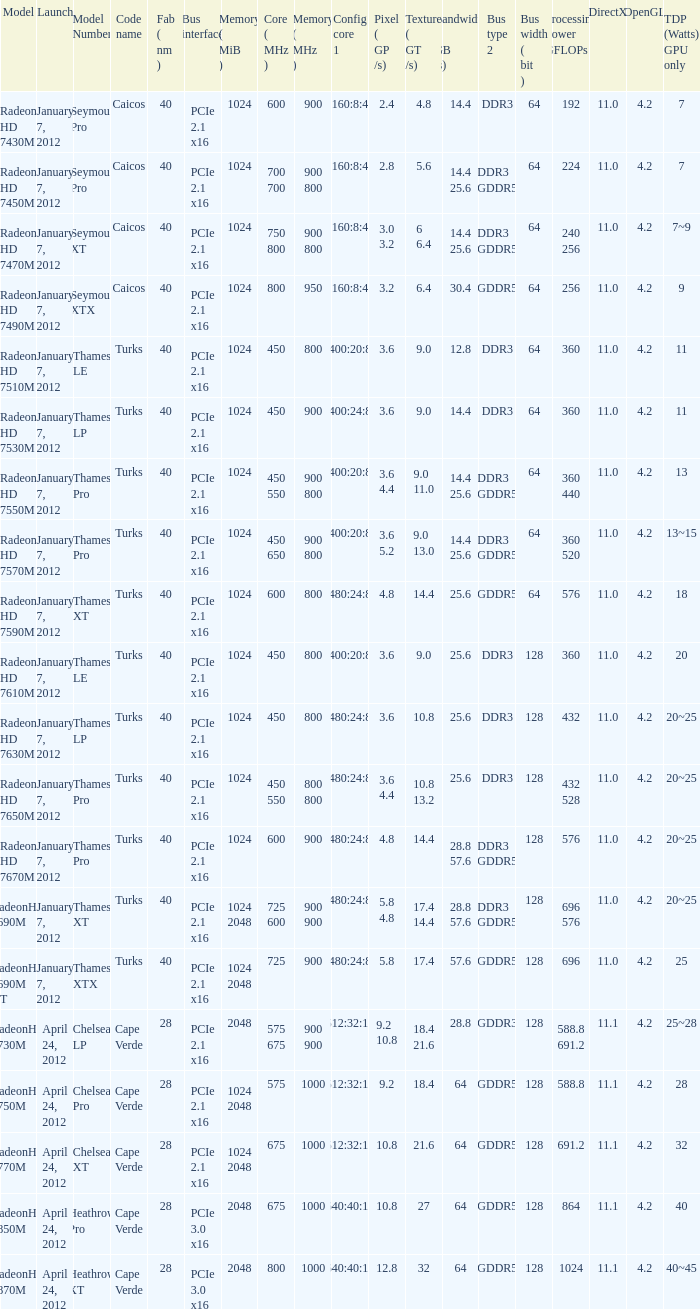How many texture (gt/s) the card has if the tdp (watts) GPU only is 18? 1.0. Could you help me parse every detail presented in this table? {'header': ['Model', 'Launch', 'Model Number', 'Code name', 'Fab ( nm )', 'Bus interface', 'Memory ( MiB )', 'Core ( MHz )', 'Memory ( MHz )', 'Config core 1', 'Pixel ( GP /s)', 'Texture ( GT /s)', 'Bandwidth ( GB /s)', 'Bus type 2', 'Bus width ( bit )', 'Processing Power GFLOPs', 'DirectX', 'OpenGL', 'TDP (Watts) GPU only'], 'rows': [['Radeon HD 7430M', 'January 7, 2012', 'Seymour Pro', 'Caicos', '40', 'PCIe 2.1 x16', '1024', '600', '900', '160:8:4', '2.4', '4.8', '14.4', 'DDR3', '64', '192', '11.0', '4.2', '7'], ['Radeon HD 7450M', 'January 7, 2012', 'Seymour Pro', 'Caicos', '40', 'PCIe 2.1 x16', '1024', '700 700', '900 800', '160:8:4', '2.8', '5.6', '14.4 25.6', 'DDR3 GDDR5', '64', '224', '11.0', '4.2', '7'], ['Radeon HD 7470M', 'January 7, 2012', 'Seymour XT', 'Caicos', '40', 'PCIe 2.1 x16', '1024', '750 800', '900 800', '160:8:4', '3.0 3.2', '6 6.4', '14.4 25.6', 'DDR3 GDDR5', '64', '240 256', '11.0', '4.2', '7~9'], ['Radeon HD 7490M', 'January 7, 2012', 'Seymour XTX', 'Caicos', '40', 'PCIe 2.1 x16', '1024', '800', '950', '160:8:4', '3.2', '6.4', '30.4', 'GDDR5', '64', '256', '11.0', '4.2', '9'], ['Radeon HD 7510M', 'January 7, 2012', 'Thames LE', 'Turks', '40', 'PCIe 2.1 x16', '1024', '450', '800', '400:20:8', '3.6', '9.0', '12.8', 'DDR3', '64', '360', '11.0', '4.2', '11'], ['Radeon HD 7530M', 'January 7, 2012', 'Thames LP', 'Turks', '40', 'PCIe 2.1 x16', '1024', '450', '900', '400:24:8', '3.6', '9.0', '14.4', 'DDR3', '64', '360', '11.0', '4.2', '11'], ['Radeon HD 7550M', 'January 7, 2012', 'Thames Pro', 'Turks', '40', 'PCIe 2.1 x16', '1024', '450 550', '900 800', '400:20:8', '3.6 4.4', '9.0 11.0', '14.4 25.6', 'DDR3 GDDR5', '64', '360 440', '11.0', '4.2', '13'], ['Radeon HD 7570M', 'January 7, 2012', 'Thames Pro', 'Turks', '40', 'PCIe 2.1 x16', '1024', '450 650', '900 800', '400:20:8', '3.6 5.2', '9.0 13.0', '14.4 25.6', 'DDR3 GDDR5', '64', '360 520', '11.0', '4.2', '13~15'], ['Radeon HD 7590M', 'January 7, 2012', 'Thames XT', 'Turks', '40', 'PCIe 2.1 x16', '1024', '600', '800', '480:24:8', '4.8', '14.4', '25.6', 'GDDR5', '64', '576', '11.0', '4.2', '18'], ['Radeon HD 7610M', 'January 7, 2012', 'Thames LE', 'Turks', '40', 'PCIe 2.1 x16', '1024', '450', '800', '400:20:8', '3.6', '9.0', '25.6', 'DDR3', '128', '360', '11.0', '4.2', '20'], ['Radeon HD 7630M', 'January 7, 2012', 'Thames LP', 'Turks', '40', 'PCIe 2.1 x16', '1024', '450', '800', '480:24:8', '3.6', '10.8', '25.6', 'DDR3', '128', '432', '11.0', '4.2', '20~25'], ['Radeon HD 7650M', 'January 7, 2012', 'Thames Pro', 'Turks', '40', 'PCIe 2.1 x16', '1024', '450 550', '800 800', '480:24:8', '3.6 4.4', '10.8 13.2', '25.6', 'DDR3', '128', '432 528', '11.0', '4.2', '20~25'], ['Radeon HD 7670M', 'January 7, 2012', 'Thames Pro', 'Turks', '40', 'PCIe 2.1 x16', '1024', '600', '900', '480:24:8', '4.8', '14.4', '28.8 57.6', 'DDR3 GDDR5', '128', '576', '11.0', '4.2', '20~25'], ['RadeonHD 7690M', 'January 7, 2012', 'Thames XT', 'Turks', '40', 'PCIe 2.1 x16', '1024 2048', '725 600', '900 900', '480:24:8', '5.8 4.8', '17.4 14.4', '28.8 57.6', 'DDR3 GDDR5', '128', '696 576', '11.0', '4.2', '20~25'], ['RadeonHD 7690M XT', 'January 7, 2012', 'Thames XTX', 'Turks', '40', 'PCIe 2.1 x16', '1024 2048', '725', '900', '480:24:8', '5.8', '17.4', '57.6', 'GDDR5', '128', '696', '11.0', '4.2', '25'], ['RadeonHD 7730M', 'April 24, 2012', 'Chelsea LP', 'Cape Verde', '28', 'PCIe 2.1 x16', '2048', '575 675', '900 900', '512:32:16', '9.2 10.8', '18.4 21.6', '28.8', 'GDDR3', '128', '588.8 691.2', '11.1', '4.2', '25~28'], ['RadeonHD 7750M', 'April 24, 2012', 'Chelsea Pro', 'Cape Verde', '28', 'PCIe 2.1 x16', '1024 2048', '575', '1000', '512:32:16', '9.2', '18.4', '64', 'GDDR5', '128', '588.8', '11.1', '4.2', '28'], ['RadeonHD 7770M', 'April 24, 2012', 'Chelsea XT', 'Cape Verde', '28', 'PCIe 2.1 x16', '1024 2048', '675', '1000', '512:32:16', '10.8', '21.6', '64', 'GDDR5', '128', '691.2', '11.1', '4.2', '32'], ['RadeonHD 7850M', 'April 24, 2012', 'Heathrow Pro', 'Cape Verde', '28', 'PCIe 3.0 x16', '2048', '675', '1000', '640:40:16', '10.8', '27', '64', 'GDDR5', '128', '864', '11.1', '4.2', '40'], ['RadeonHD 7870M', 'April 24, 2012', 'Heathrow XT', 'Cape Verde', '28', 'PCIe 3.0 x16', '2048', '800', '1000', '640:40:16', '12.8', '32', '64', 'GDDR5', '128', '1024', '11.1', '4.2', '40~45']]} 